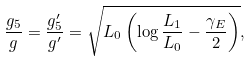Convert formula to latex. <formula><loc_0><loc_0><loc_500><loc_500>\frac { g _ { 5 } } { g } = \frac { g _ { 5 } ^ { \prime } } { g ^ { \prime } } = \sqrt { L _ { 0 } \left ( \log \frac { L _ { 1 } } { L _ { 0 } } - \frac { \gamma _ { E } } { 2 } \right ) } ,</formula> 